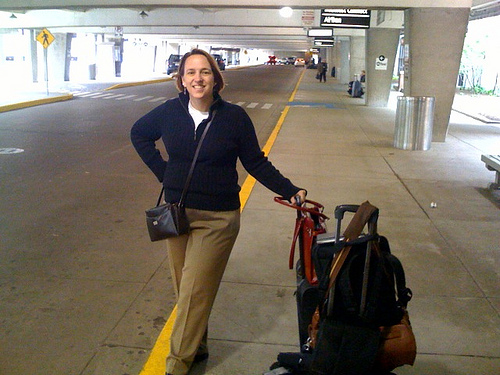Based on her attire, what can we infer about her travel plans? Based on her attire, which is casual yet organized, we can infer that her travel plans might be practical and well-thought-out. Her comfortable clothing suggests that she values ease and practicality during her journey. She is dressed for comfort during what appears to be a potentially longer journey, indicating that she might be prepared for varying travel conditions. If this were a scene in a movie, what genre would it be? If this were a scene in a movie, it could fit well into the adventure or drama genre. The setting of a terminal and the poised demeanor of the woman suggest the beginning of a significant journey, either physically or metaphorically. It might also fit into a romantic comedy where her travels lead her to unexpected personal encounters or humorous situations. 